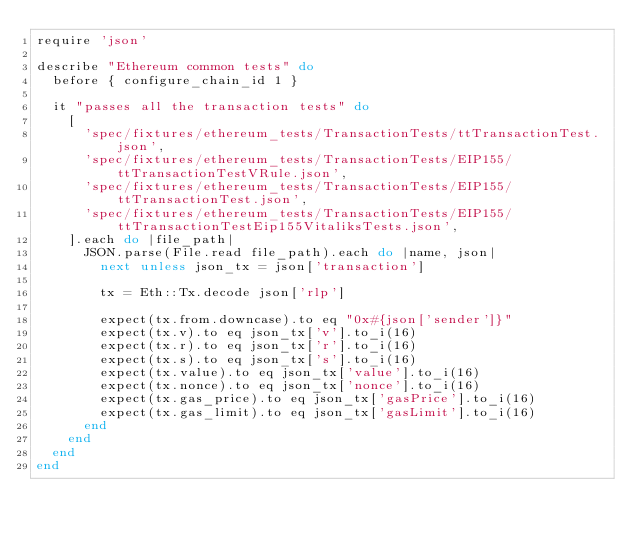Convert code to text. <code><loc_0><loc_0><loc_500><loc_500><_Ruby_>require 'json'

describe "Ethereum common tests" do
  before { configure_chain_id 1 }

  it "passes all the transaction tests" do
    [
      'spec/fixtures/ethereum_tests/TransactionTests/ttTransactionTest.json',
      'spec/fixtures/ethereum_tests/TransactionTests/EIP155/ttTransactionTestVRule.json',
      'spec/fixtures/ethereum_tests/TransactionTests/EIP155/ttTransactionTest.json',
      'spec/fixtures/ethereum_tests/TransactionTests/EIP155/ttTransactionTestEip155VitaliksTests.json',
    ].each do |file_path|
      JSON.parse(File.read file_path).each do |name, json|
        next unless json_tx = json['transaction']

        tx = Eth::Tx.decode json['rlp']

        expect(tx.from.downcase).to eq "0x#{json['sender']}"
        expect(tx.v).to eq json_tx['v'].to_i(16)
        expect(tx.r).to eq json_tx['r'].to_i(16)
        expect(tx.s).to eq json_tx['s'].to_i(16)
        expect(tx.value).to eq json_tx['value'].to_i(16)
        expect(tx.nonce).to eq json_tx['nonce'].to_i(16)
        expect(tx.gas_price).to eq json_tx['gasPrice'].to_i(16)
        expect(tx.gas_limit).to eq json_tx['gasLimit'].to_i(16)
      end
    end
  end
end
</code> 